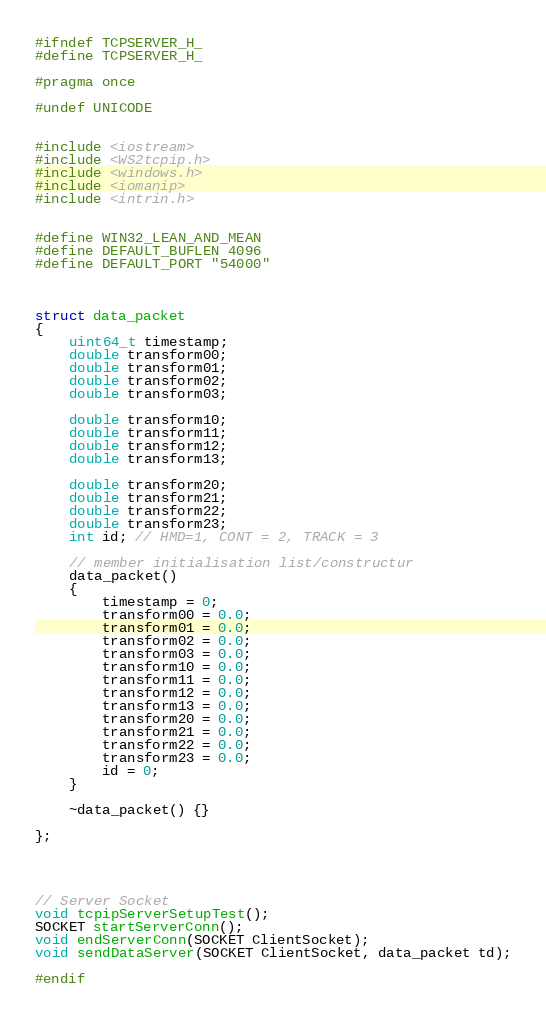<code> <loc_0><loc_0><loc_500><loc_500><_C_>#ifndef TCPSERVER_H_
#define TCPSERVER_H_

#pragma once

#undef UNICODE


#include <iostream>
#include <WS2tcpip.h>
#include <windows.h>
#include <iomanip>
#include <intrin.h>


#define WIN32_LEAN_AND_MEAN
#define DEFAULT_BUFLEN 4096
#define DEFAULT_PORT "54000"



struct data_packet
{
	uint64_t timestamp;
	double transform00;
	double transform01;
	double transform02;
	double transform03;

	double transform10;
	double transform11;
	double transform12;
	double transform13;

	double transform20;
	double transform21;
	double transform22;
	double transform23;
	int id; // HMD=1, CONT = 2, TRACK = 3

	// member initialisation list/constructur
	data_packet()
	{
		timestamp = 0;
		transform00 = 0.0;
		transform01 = 0.0;
		transform02 = 0.0;
		transform03 = 0.0;
		transform10 = 0.0;
		transform11 = 0.0;
		transform12 = 0.0;
		transform13 = 0.0;
		transform20 = 0.0;
		transform21 = 0.0;
		transform22 = 0.0;
		transform23 = 0.0;
		id = 0;
	}

	~data_packet() {}

};




// Server Socket
void tcpipServerSetupTest();
SOCKET startServerConn();
void endServerConn(SOCKET ClientSocket);
void sendDataServer(SOCKET ClientSocket, data_packet td);

#endif
</code> 